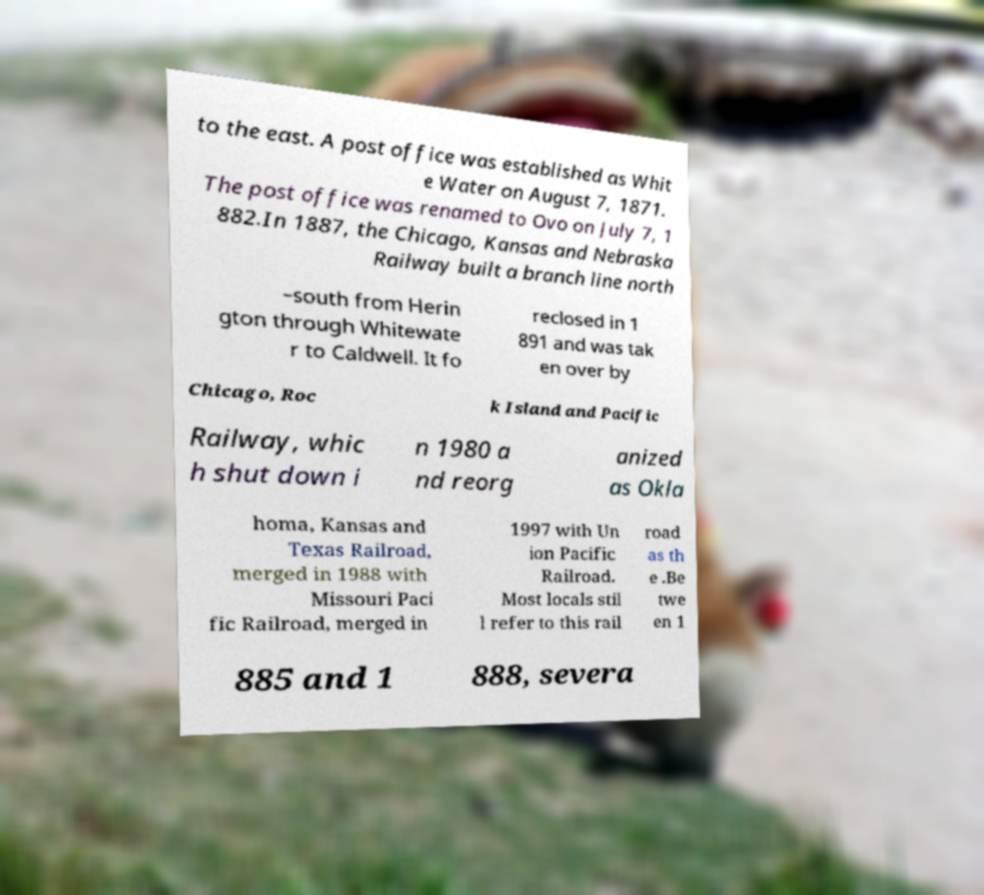For documentation purposes, I need the text within this image transcribed. Could you provide that? to the east. A post office was established as Whit e Water on August 7, 1871. The post office was renamed to Ovo on July 7, 1 882.In 1887, the Chicago, Kansas and Nebraska Railway built a branch line north –south from Herin gton through Whitewate r to Caldwell. It fo reclosed in 1 891 and was tak en over by Chicago, Roc k Island and Pacific Railway, whic h shut down i n 1980 a nd reorg anized as Okla homa, Kansas and Texas Railroad, merged in 1988 with Missouri Paci fic Railroad, merged in 1997 with Un ion Pacific Railroad. Most locals stil l refer to this rail road as th e .Be twe en 1 885 and 1 888, severa 